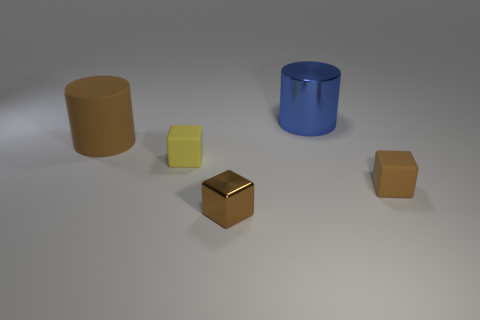There is a cube that is the same color as the small shiny object; what is its material?
Offer a terse response. Rubber. There is a block that is the same color as the tiny metal thing; what size is it?
Your answer should be compact. Small. Is the size of the brown matte object that is in front of the large rubber object the same as the shiny thing that is behind the brown rubber cylinder?
Provide a short and direct response. No. What number of other objects are the same shape as the tiny brown shiny thing?
Keep it short and to the point. 2. What material is the small block that is behind the small thing to the right of the tiny brown shiny thing made of?
Make the answer very short. Rubber. How many shiny things are either cylinders or small brown objects?
Your response must be concise. 2. Is there a big cylinder that is in front of the big object that is on the right side of the tiny yellow rubber thing?
Offer a very short reply. Yes. What number of things are either tiny cubes on the right side of the small metal object or rubber objects left of the brown metallic cube?
Provide a short and direct response. 3. Are there any other things of the same color as the rubber cylinder?
Your answer should be very brief. Yes. There is a small cube in front of the tiny brown thing on the right side of the metallic thing behind the tiny brown metallic cube; what is its color?
Provide a succinct answer. Brown. 